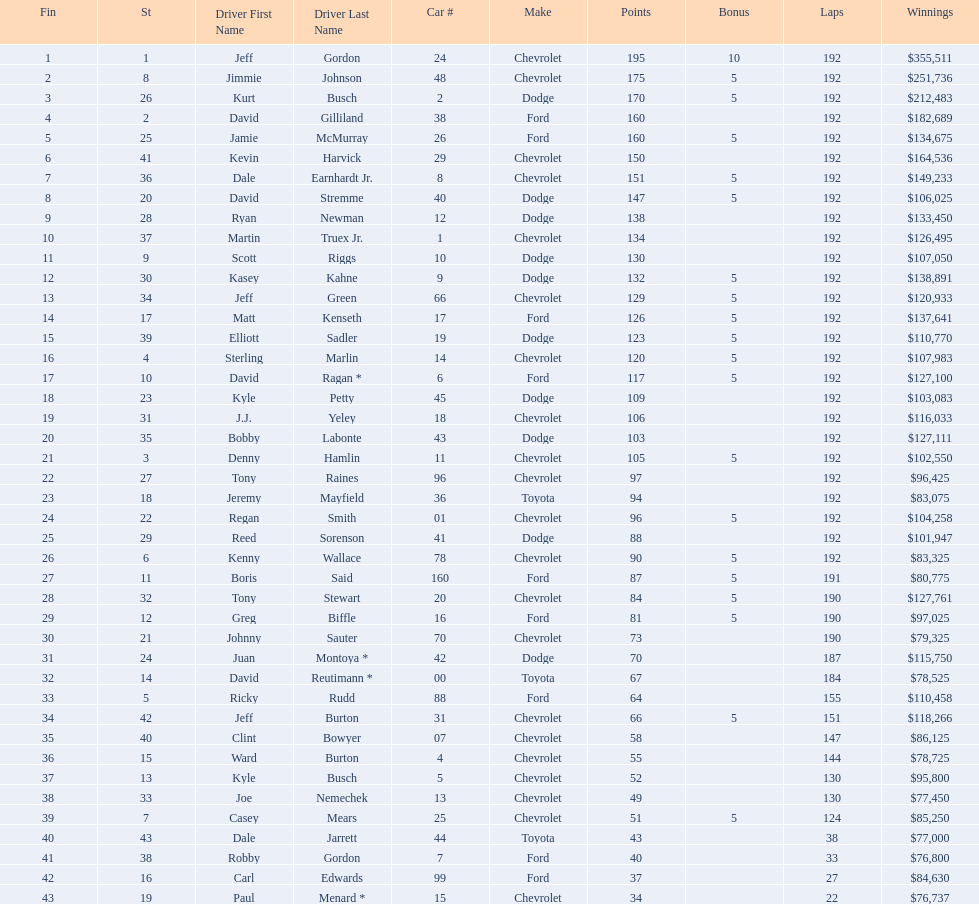What was jimmie johnson's winnings? $251,736. 